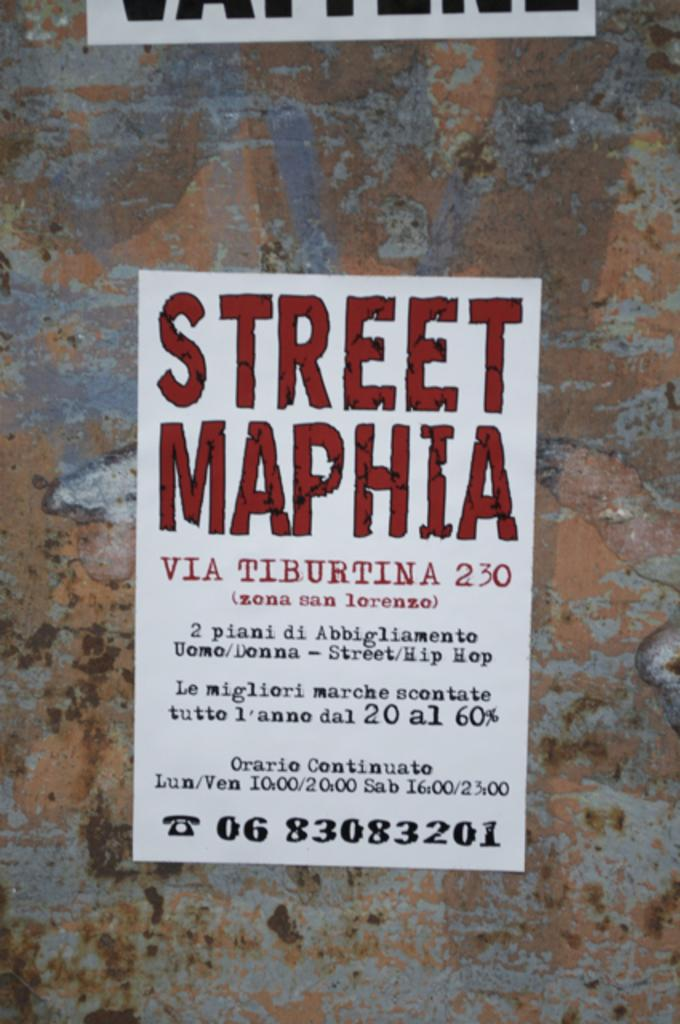<image>
Summarize the visual content of the image. a Street Maphia sign on a dark surface 